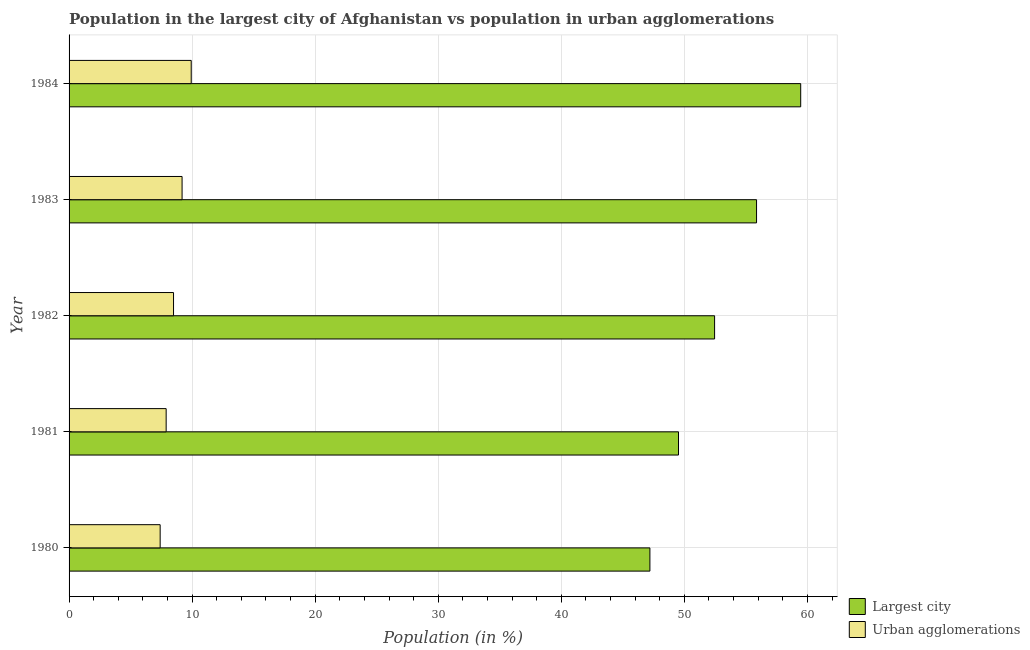How many different coloured bars are there?
Offer a terse response. 2. Are the number of bars per tick equal to the number of legend labels?
Your response must be concise. Yes. How many bars are there on the 2nd tick from the bottom?
Provide a short and direct response. 2. What is the label of the 5th group of bars from the top?
Your answer should be very brief. 1980. What is the population in the largest city in 1981?
Your answer should be very brief. 49.52. Across all years, what is the maximum population in the largest city?
Offer a very short reply. 59.45. Across all years, what is the minimum population in urban agglomerations?
Your response must be concise. 7.4. In which year was the population in the largest city minimum?
Your response must be concise. 1980. What is the total population in urban agglomerations in the graph?
Provide a short and direct response. 42.89. What is the difference between the population in the largest city in 1983 and that in 1984?
Your response must be concise. -3.59. What is the difference between the population in the largest city in 1981 and the population in urban agglomerations in 1982?
Provide a succinct answer. 41.04. What is the average population in the largest city per year?
Your answer should be compact. 52.9. In the year 1984, what is the difference between the population in the largest city and population in urban agglomerations?
Keep it short and to the point. 49.53. In how many years, is the population in the largest city greater than 20 %?
Offer a terse response. 5. What is the ratio of the population in the largest city in 1980 to that in 1982?
Offer a very short reply. 0.9. Is the population in the largest city in 1980 less than that in 1983?
Your answer should be compact. Yes. What is the difference between the highest and the second highest population in urban agglomerations?
Provide a short and direct response. 0.74. What is the difference between the highest and the lowest population in urban agglomerations?
Offer a very short reply. 2.53. What does the 1st bar from the top in 1983 represents?
Make the answer very short. Urban agglomerations. What does the 1st bar from the bottom in 1981 represents?
Offer a very short reply. Largest city. Are all the bars in the graph horizontal?
Give a very brief answer. Yes. What is the difference between two consecutive major ticks on the X-axis?
Keep it short and to the point. 10. Does the graph contain grids?
Give a very brief answer. Yes. Where does the legend appear in the graph?
Your answer should be very brief. Bottom right. How are the legend labels stacked?
Offer a terse response. Vertical. What is the title of the graph?
Offer a very short reply. Population in the largest city of Afghanistan vs population in urban agglomerations. What is the label or title of the Y-axis?
Provide a short and direct response. Year. What is the Population (in %) of Largest city in 1980?
Make the answer very short. 47.2. What is the Population (in %) in Urban agglomerations in 1980?
Your answer should be compact. 7.4. What is the Population (in %) in Largest city in 1981?
Provide a succinct answer. 49.52. What is the Population (in %) in Urban agglomerations in 1981?
Give a very brief answer. 7.89. What is the Population (in %) of Largest city in 1982?
Your answer should be very brief. 52.46. What is the Population (in %) in Urban agglomerations in 1982?
Offer a very short reply. 8.49. What is the Population (in %) in Largest city in 1983?
Your answer should be very brief. 55.87. What is the Population (in %) of Urban agglomerations in 1983?
Make the answer very short. 9.18. What is the Population (in %) of Largest city in 1984?
Make the answer very short. 59.45. What is the Population (in %) of Urban agglomerations in 1984?
Provide a short and direct response. 9.93. Across all years, what is the maximum Population (in %) in Largest city?
Your answer should be very brief. 59.45. Across all years, what is the maximum Population (in %) in Urban agglomerations?
Offer a very short reply. 9.93. Across all years, what is the minimum Population (in %) in Largest city?
Your answer should be compact. 47.2. Across all years, what is the minimum Population (in %) of Urban agglomerations?
Your answer should be compact. 7.4. What is the total Population (in %) of Largest city in the graph?
Ensure brevity in your answer.  264.5. What is the total Population (in %) in Urban agglomerations in the graph?
Provide a succinct answer. 42.89. What is the difference between the Population (in %) in Largest city in 1980 and that in 1981?
Give a very brief answer. -2.32. What is the difference between the Population (in %) of Urban agglomerations in 1980 and that in 1981?
Offer a terse response. -0.49. What is the difference between the Population (in %) in Largest city in 1980 and that in 1982?
Your response must be concise. -5.26. What is the difference between the Population (in %) of Urban agglomerations in 1980 and that in 1982?
Your response must be concise. -1.09. What is the difference between the Population (in %) in Largest city in 1980 and that in 1983?
Your answer should be compact. -8.67. What is the difference between the Population (in %) of Urban agglomerations in 1980 and that in 1983?
Keep it short and to the point. -1.78. What is the difference between the Population (in %) in Largest city in 1980 and that in 1984?
Offer a terse response. -12.26. What is the difference between the Population (in %) in Urban agglomerations in 1980 and that in 1984?
Make the answer very short. -2.53. What is the difference between the Population (in %) in Largest city in 1981 and that in 1982?
Provide a short and direct response. -2.93. What is the difference between the Population (in %) in Urban agglomerations in 1981 and that in 1982?
Give a very brief answer. -0.6. What is the difference between the Population (in %) in Largest city in 1981 and that in 1983?
Ensure brevity in your answer.  -6.34. What is the difference between the Population (in %) in Urban agglomerations in 1981 and that in 1983?
Offer a very short reply. -1.29. What is the difference between the Population (in %) in Largest city in 1981 and that in 1984?
Make the answer very short. -9.93. What is the difference between the Population (in %) in Urban agglomerations in 1981 and that in 1984?
Give a very brief answer. -2.04. What is the difference between the Population (in %) in Largest city in 1982 and that in 1983?
Offer a terse response. -3.41. What is the difference between the Population (in %) in Urban agglomerations in 1982 and that in 1983?
Your answer should be very brief. -0.69. What is the difference between the Population (in %) in Largest city in 1982 and that in 1984?
Ensure brevity in your answer.  -7. What is the difference between the Population (in %) of Urban agglomerations in 1982 and that in 1984?
Make the answer very short. -1.44. What is the difference between the Population (in %) of Largest city in 1983 and that in 1984?
Provide a short and direct response. -3.59. What is the difference between the Population (in %) in Urban agglomerations in 1983 and that in 1984?
Offer a very short reply. -0.74. What is the difference between the Population (in %) of Largest city in 1980 and the Population (in %) of Urban agglomerations in 1981?
Provide a succinct answer. 39.31. What is the difference between the Population (in %) of Largest city in 1980 and the Population (in %) of Urban agglomerations in 1982?
Provide a succinct answer. 38.71. What is the difference between the Population (in %) in Largest city in 1980 and the Population (in %) in Urban agglomerations in 1983?
Provide a short and direct response. 38.02. What is the difference between the Population (in %) of Largest city in 1980 and the Population (in %) of Urban agglomerations in 1984?
Provide a short and direct response. 37.27. What is the difference between the Population (in %) of Largest city in 1981 and the Population (in %) of Urban agglomerations in 1982?
Make the answer very short. 41.03. What is the difference between the Population (in %) in Largest city in 1981 and the Population (in %) in Urban agglomerations in 1983?
Your answer should be compact. 40.34. What is the difference between the Population (in %) in Largest city in 1981 and the Population (in %) in Urban agglomerations in 1984?
Provide a short and direct response. 39.6. What is the difference between the Population (in %) of Largest city in 1982 and the Population (in %) of Urban agglomerations in 1983?
Give a very brief answer. 43.27. What is the difference between the Population (in %) of Largest city in 1982 and the Population (in %) of Urban agglomerations in 1984?
Your answer should be very brief. 42.53. What is the difference between the Population (in %) of Largest city in 1983 and the Population (in %) of Urban agglomerations in 1984?
Ensure brevity in your answer.  45.94. What is the average Population (in %) of Largest city per year?
Make the answer very short. 52.9. What is the average Population (in %) in Urban agglomerations per year?
Offer a very short reply. 8.58. In the year 1980, what is the difference between the Population (in %) of Largest city and Population (in %) of Urban agglomerations?
Your answer should be compact. 39.8. In the year 1981, what is the difference between the Population (in %) in Largest city and Population (in %) in Urban agglomerations?
Provide a short and direct response. 41.63. In the year 1982, what is the difference between the Population (in %) in Largest city and Population (in %) in Urban agglomerations?
Offer a terse response. 43.97. In the year 1983, what is the difference between the Population (in %) in Largest city and Population (in %) in Urban agglomerations?
Your answer should be compact. 46.68. In the year 1984, what is the difference between the Population (in %) in Largest city and Population (in %) in Urban agglomerations?
Offer a very short reply. 49.53. What is the ratio of the Population (in %) in Largest city in 1980 to that in 1981?
Your answer should be compact. 0.95. What is the ratio of the Population (in %) of Urban agglomerations in 1980 to that in 1981?
Make the answer very short. 0.94. What is the ratio of the Population (in %) in Largest city in 1980 to that in 1982?
Offer a very short reply. 0.9. What is the ratio of the Population (in %) of Urban agglomerations in 1980 to that in 1982?
Offer a very short reply. 0.87. What is the ratio of the Population (in %) in Largest city in 1980 to that in 1983?
Your response must be concise. 0.84. What is the ratio of the Population (in %) of Urban agglomerations in 1980 to that in 1983?
Your answer should be very brief. 0.81. What is the ratio of the Population (in %) in Largest city in 1980 to that in 1984?
Offer a terse response. 0.79. What is the ratio of the Population (in %) in Urban agglomerations in 1980 to that in 1984?
Your answer should be very brief. 0.75. What is the ratio of the Population (in %) in Largest city in 1981 to that in 1982?
Give a very brief answer. 0.94. What is the ratio of the Population (in %) of Urban agglomerations in 1981 to that in 1982?
Keep it short and to the point. 0.93. What is the ratio of the Population (in %) of Largest city in 1981 to that in 1983?
Provide a succinct answer. 0.89. What is the ratio of the Population (in %) of Urban agglomerations in 1981 to that in 1983?
Your response must be concise. 0.86. What is the ratio of the Population (in %) in Largest city in 1981 to that in 1984?
Offer a terse response. 0.83. What is the ratio of the Population (in %) of Urban agglomerations in 1981 to that in 1984?
Your response must be concise. 0.79. What is the ratio of the Population (in %) of Largest city in 1982 to that in 1983?
Provide a short and direct response. 0.94. What is the ratio of the Population (in %) in Urban agglomerations in 1982 to that in 1983?
Your answer should be compact. 0.92. What is the ratio of the Population (in %) in Largest city in 1982 to that in 1984?
Your response must be concise. 0.88. What is the ratio of the Population (in %) of Urban agglomerations in 1982 to that in 1984?
Provide a short and direct response. 0.86. What is the ratio of the Population (in %) of Largest city in 1983 to that in 1984?
Your answer should be compact. 0.94. What is the ratio of the Population (in %) in Urban agglomerations in 1983 to that in 1984?
Offer a very short reply. 0.93. What is the difference between the highest and the second highest Population (in %) of Largest city?
Keep it short and to the point. 3.59. What is the difference between the highest and the second highest Population (in %) in Urban agglomerations?
Offer a very short reply. 0.74. What is the difference between the highest and the lowest Population (in %) of Largest city?
Give a very brief answer. 12.26. What is the difference between the highest and the lowest Population (in %) of Urban agglomerations?
Your answer should be very brief. 2.53. 